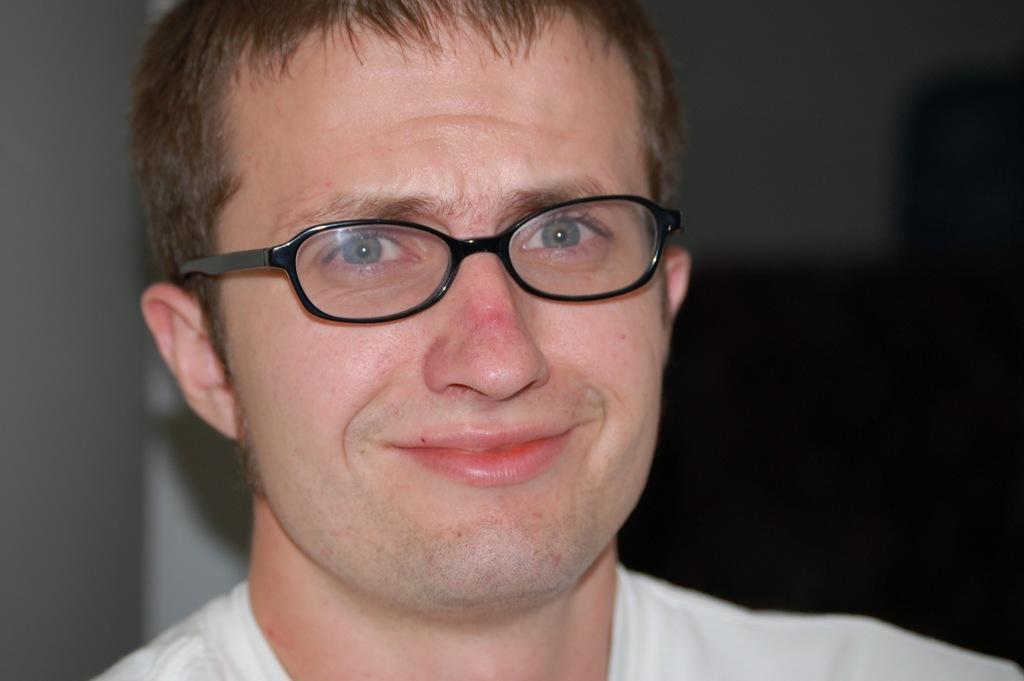Can you describe this image briefly? In this picture I can see a man, he is wearing the spectacles. 